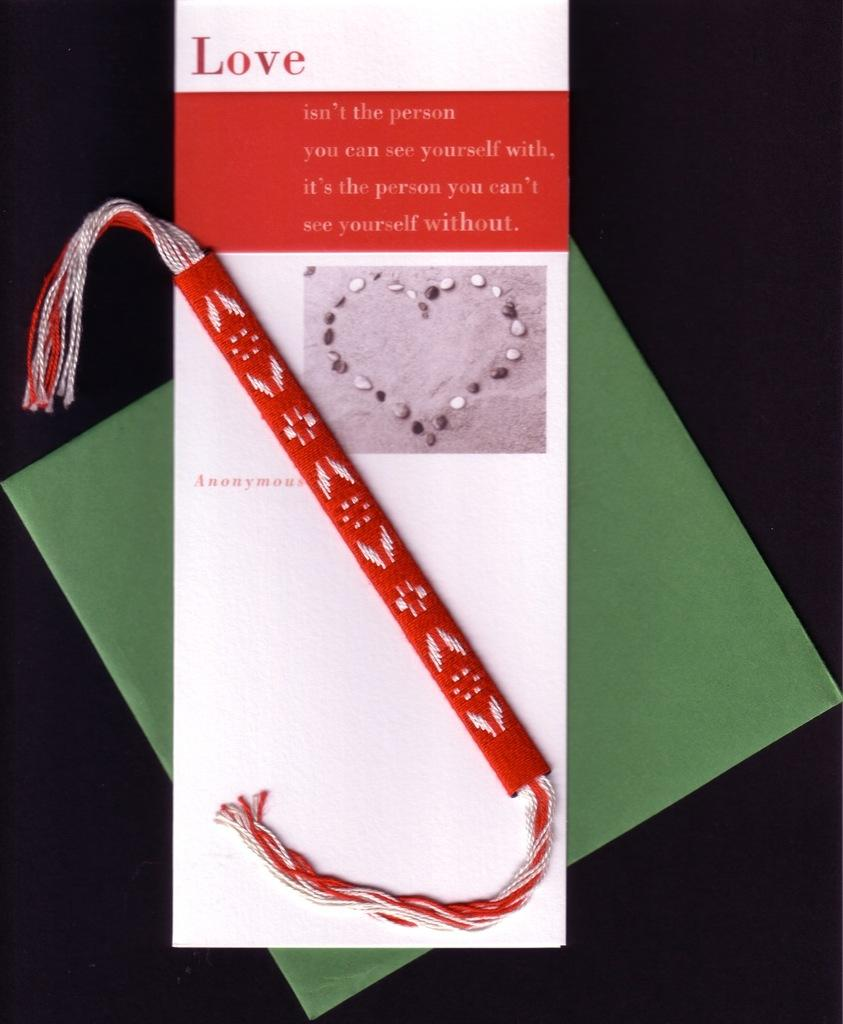<image>
Summarize the visual content of the image. A card has the word love on the top and a green background. 